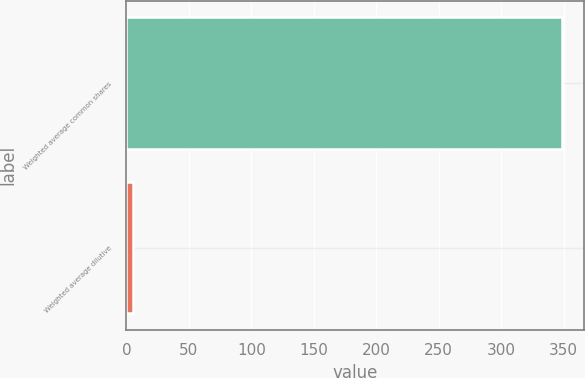<chart> <loc_0><loc_0><loc_500><loc_500><bar_chart><fcel>Weighted average common shares<fcel>Weighted average dilutive<nl><fcel>348.48<fcel>5.6<nl></chart> 